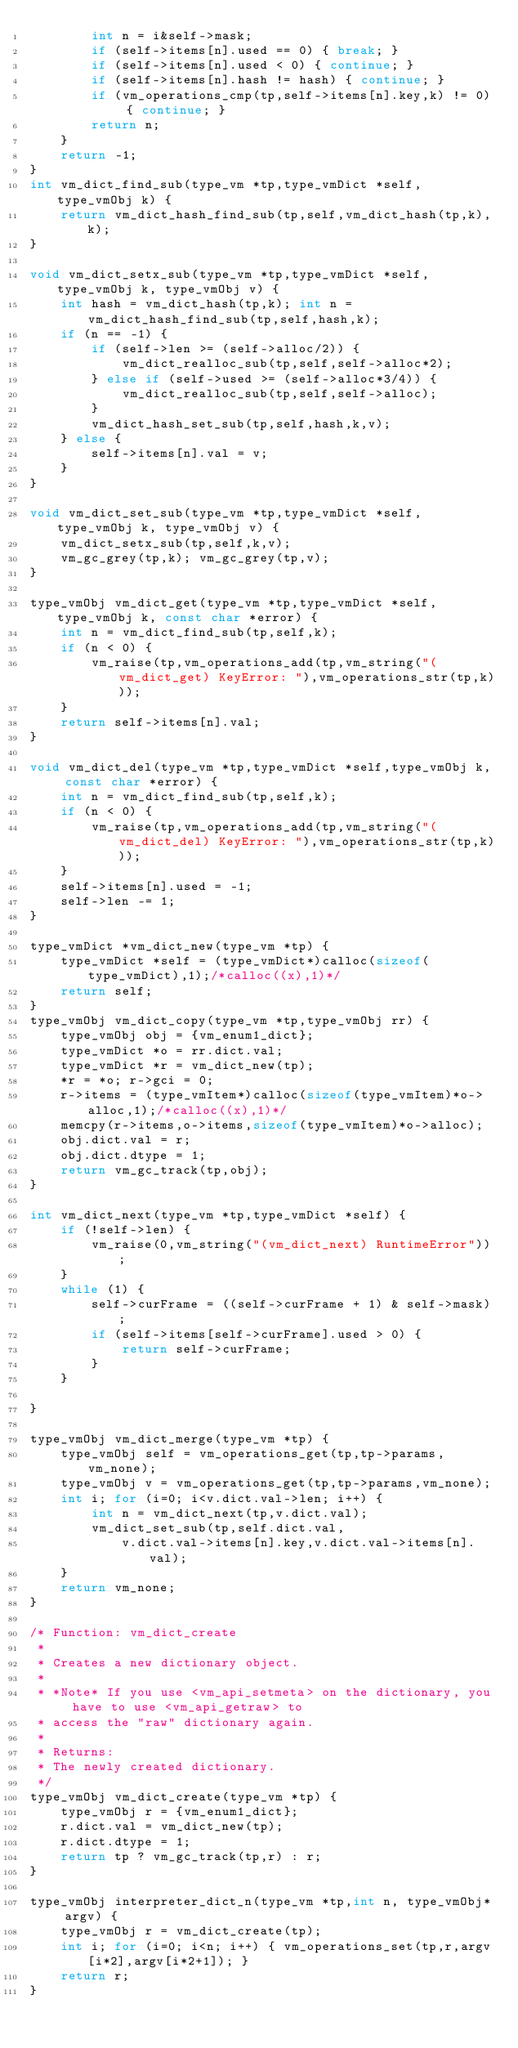<code> <loc_0><loc_0><loc_500><loc_500><_C_>        int n = i&self->mask;
        if (self->items[n].used == 0) { break; }
        if (self->items[n].used < 0) { continue; }
        if (self->items[n].hash != hash) { continue; }
        if (vm_operations_cmp(tp,self->items[n].key,k) != 0) { continue; }
        return n;
    }
    return -1;
}
int vm_dict_find_sub(type_vm *tp,type_vmDict *self,type_vmObj k) {
    return vm_dict_hash_find_sub(tp,self,vm_dict_hash(tp,k),k);
}

void vm_dict_setx_sub(type_vm *tp,type_vmDict *self,type_vmObj k, type_vmObj v) {
    int hash = vm_dict_hash(tp,k); int n = vm_dict_hash_find_sub(tp,self,hash,k);
    if (n == -1) {
        if (self->len >= (self->alloc/2)) {
            vm_dict_realloc_sub(tp,self,self->alloc*2);
        } else if (self->used >= (self->alloc*3/4)) {
            vm_dict_realloc_sub(tp,self,self->alloc);
        }
        vm_dict_hash_set_sub(tp,self,hash,k,v);
    } else {
        self->items[n].val = v;
    }
}

void vm_dict_set_sub(type_vm *tp,type_vmDict *self,type_vmObj k, type_vmObj v) {
    vm_dict_setx_sub(tp,self,k,v);
    vm_gc_grey(tp,k); vm_gc_grey(tp,v);
}

type_vmObj vm_dict_get(type_vm *tp,type_vmDict *self,type_vmObj k, const char *error) {
    int n = vm_dict_find_sub(tp,self,k);
    if (n < 0) {
        vm_raise(tp,vm_operations_add(tp,vm_string("(vm_dict_get) KeyError: "),vm_operations_str(tp,k)));
    }
    return self->items[n].val;
}

void vm_dict_del(type_vm *tp,type_vmDict *self,type_vmObj k, const char *error) {
    int n = vm_dict_find_sub(tp,self,k);
    if (n < 0) {
        vm_raise(tp,vm_operations_add(tp,vm_string("(vm_dict_del) KeyError: "),vm_operations_str(tp,k)));
    }
    self->items[n].used = -1;
    self->len -= 1;
}

type_vmDict *vm_dict_new(type_vm *tp) {
    type_vmDict *self = (type_vmDict*)calloc(sizeof(type_vmDict),1);/*calloc((x),1)*/
    return self;
}
type_vmObj vm_dict_copy(type_vm *tp,type_vmObj rr) {
    type_vmObj obj = {vm_enum1_dict};
    type_vmDict *o = rr.dict.val;
    type_vmDict *r = vm_dict_new(tp);
    *r = *o; r->gci = 0;
    r->items = (type_vmItem*)calloc(sizeof(type_vmItem)*o->alloc,1);/*calloc((x),1)*/
    memcpy(r->items,o->items,sizeof(type_vmItem)*o->alloc);
    obj.dict.val = r;
    obj.dict.dtype = 1;
    return vm_gc_track(tp,obj);
}

int vm_dict_next(type_vm *tp,type_vmDict *self) {
    if (!self->len) {
        vm_raise(0,vm_string("(vm_dict_next) RuntimeError"));
    }
    while (1) {
        self->curFrame = ((self->curFrame + 1) & self->mask);
        if (self->items[self->curFrame].used > 0) {
            return self->curFrame;
        }
    }

}

type_vmObj vm_dict_merge(type_vm *tp) {
    type_vmObj self = vm_operations_get(tp,tp->params,vm_none);
    type_vmObj v = vm_operations_get(tp,tp->params,vm_none);
    int i; for (i=0; i<v.dict.val->len; i++) {
        int n = vm_dict_next(tp,v.dict.val);
        vm_dict_set_sub(tp,self.dict.val,
            v.dict.val->items[n].key,v.dict.val->items[n].val);
    }
    return vm_none;
}

/* Function: vm_dict_create
 *
 * Creates a new dictionary object.
 *
 * *Note* If you use <vm_api_setmeta> on the dictionary, you have to use <vm_api_getraw> to
 * access the "raw" dictionary again.
 *
 * Returns:
 * The newly created dictionary.
 */
type_vmObj vm_dict_create(type_vm *tp) {
    type_vmObj r = {vm_enum1_dict};
    r.dict.val = vm_dict_new(tp);
    r.dict.dtype = 1;
    return tp ? vm_gc_track(tp,r) : r;
}

type_vmObj interpreter_dict_n(type_vm *tp,int n, type_vmObj* argv) {
    type_vmObj r = vm_dict_create(tp);
    int i; for (i=0; i<n; i++) { vm_operations_set(tp,r,argv[i*2],argv[i*2+1]); }
    return r;
}


</code> 